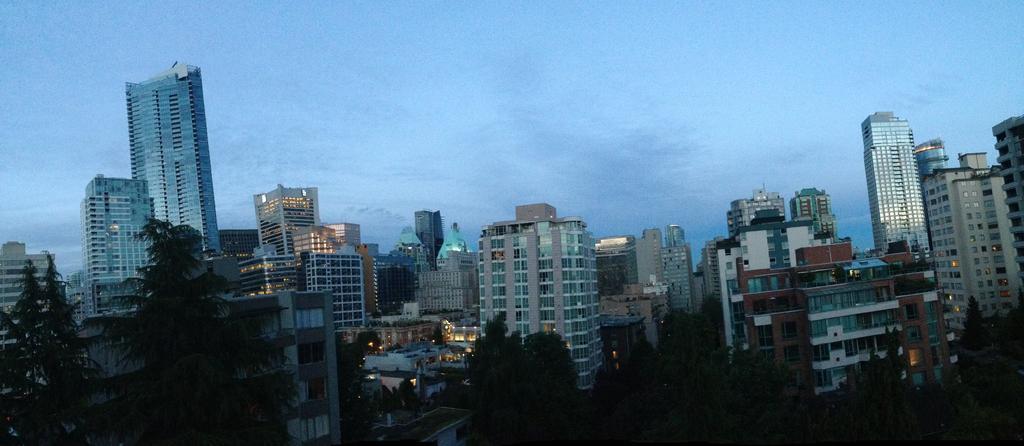Could you give a brief overview of what you see in this image? There are few buildings and there are trees in the left corner. 